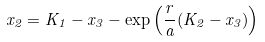Convert formula to latex. <formula><loc_0><loc_0><loc_500><loc_500>x _ { 2 } = K _ { 1 } - x _ { 3 } - \exp \left ( \frac { r } { a } ( K _ { 2 } - x _ { 3 } ) \right )</formula> 